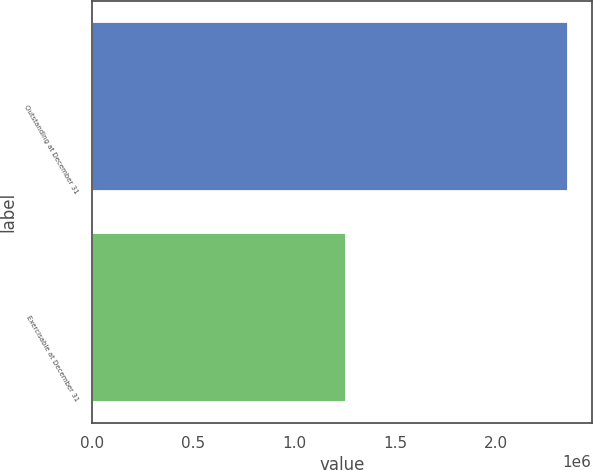Convert chart. <chart><loc_0><loc_0><loc_500><loc_500><bar_chart><fcel>Outstanding at December 31<fcel>Exercisable at December 31<nl><fcel>2.35391e+06<fcel>1.25808e+06<nl></chart> 